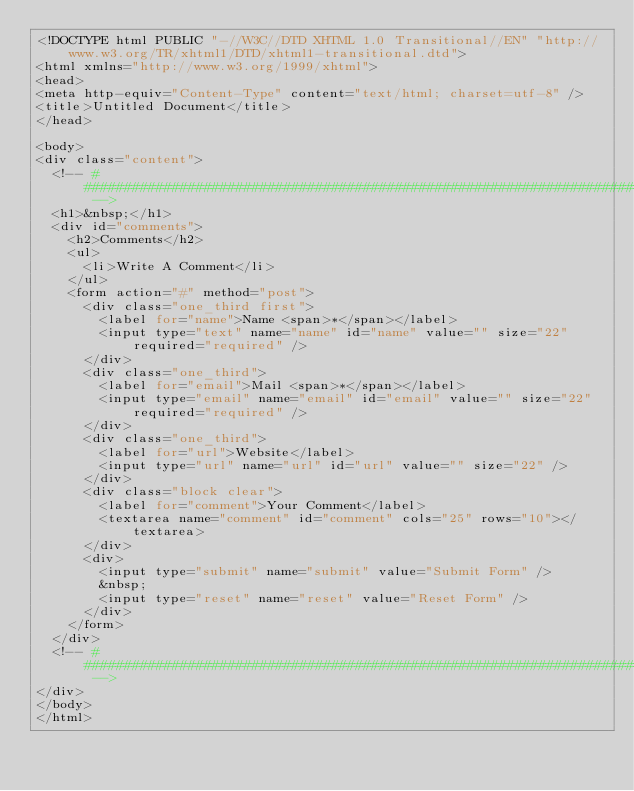<code> <loc_0><loc_0><loc_500><loc_500><_PHP_><!DOCTYPE html PUBLIC "-//W3C//DTD XHTML 1.0 Transitional//EN" "http://www.w3.org/TR/xhtml1/DTD/xhtml1-transitional.dtd">
<html xmlns="http://www.w3.org/1999/xhtml">
<head>
<meta http-equiv="Content-Type" content="text/html; charset=utf-8" />
<title>Untitled Document</title>
</head>

<body>
<div class="content">
  <!-- ################################################################################################ -->
  <h1>&nbsp;</h1>
  <div id="comments">
    <h2>Comments</h2>
    <ul>
      <li>Write A Comment</li>
    </ul>
    <form action="#" method="post">
      <div class="one_third first">
        <label for="name">Name <span>*</span></label>
        <input type="text" name="name" id="name" value="" size="22" required="required" />
      </div>
      <div class="one_third">
        <label for="email">Mail <span>*</span></label>
        <input type="email" name="email" id="email" value="" size="22" required="required" />
      </div>
      <div class="one_third">
        <label for="url">Website</label>
        <input type="url" name="url" id="url" value="" size="22" />
      </div>
      <div class="block clear">
        <label for="comment">Your Comment</label>
        <textarea name="comment" id="comment" cols="25" rows="10"></textarea>
      </div>
      <div>
        <input type="submit" name="submit" value="Submit Form" />
        &nbsp;
        <input type="reset" name="reset" value="Reset Form" />
      </div>
    </form>
  </div>
  <!-- ################################################################################################ -->
</div>
</body>
</html></code> 